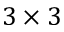<formula> <loc_0><loc_0><loc_500><loc_500>3 \times 3</formula> 